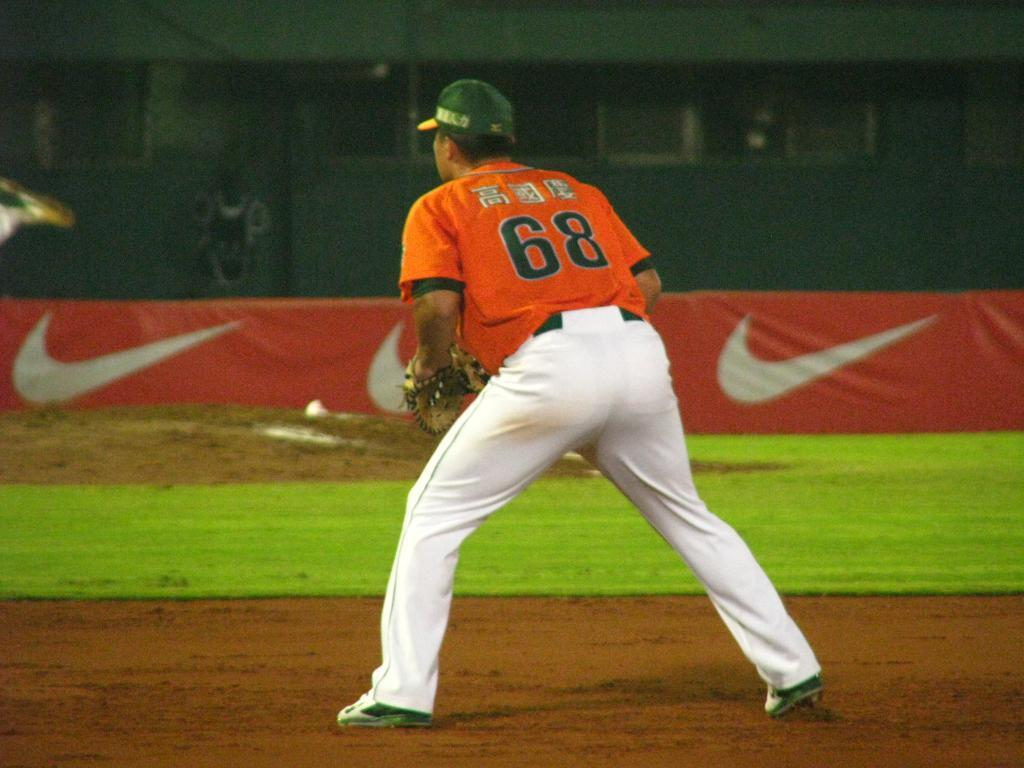<image>
Relay a brief, clear account of the picture shown. Baseball player standing on the field numbered 68 ready to react to the play. 